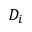<formula> <loc_0><loc_0><loc_500><loc_500>D _ { i }</formula> 